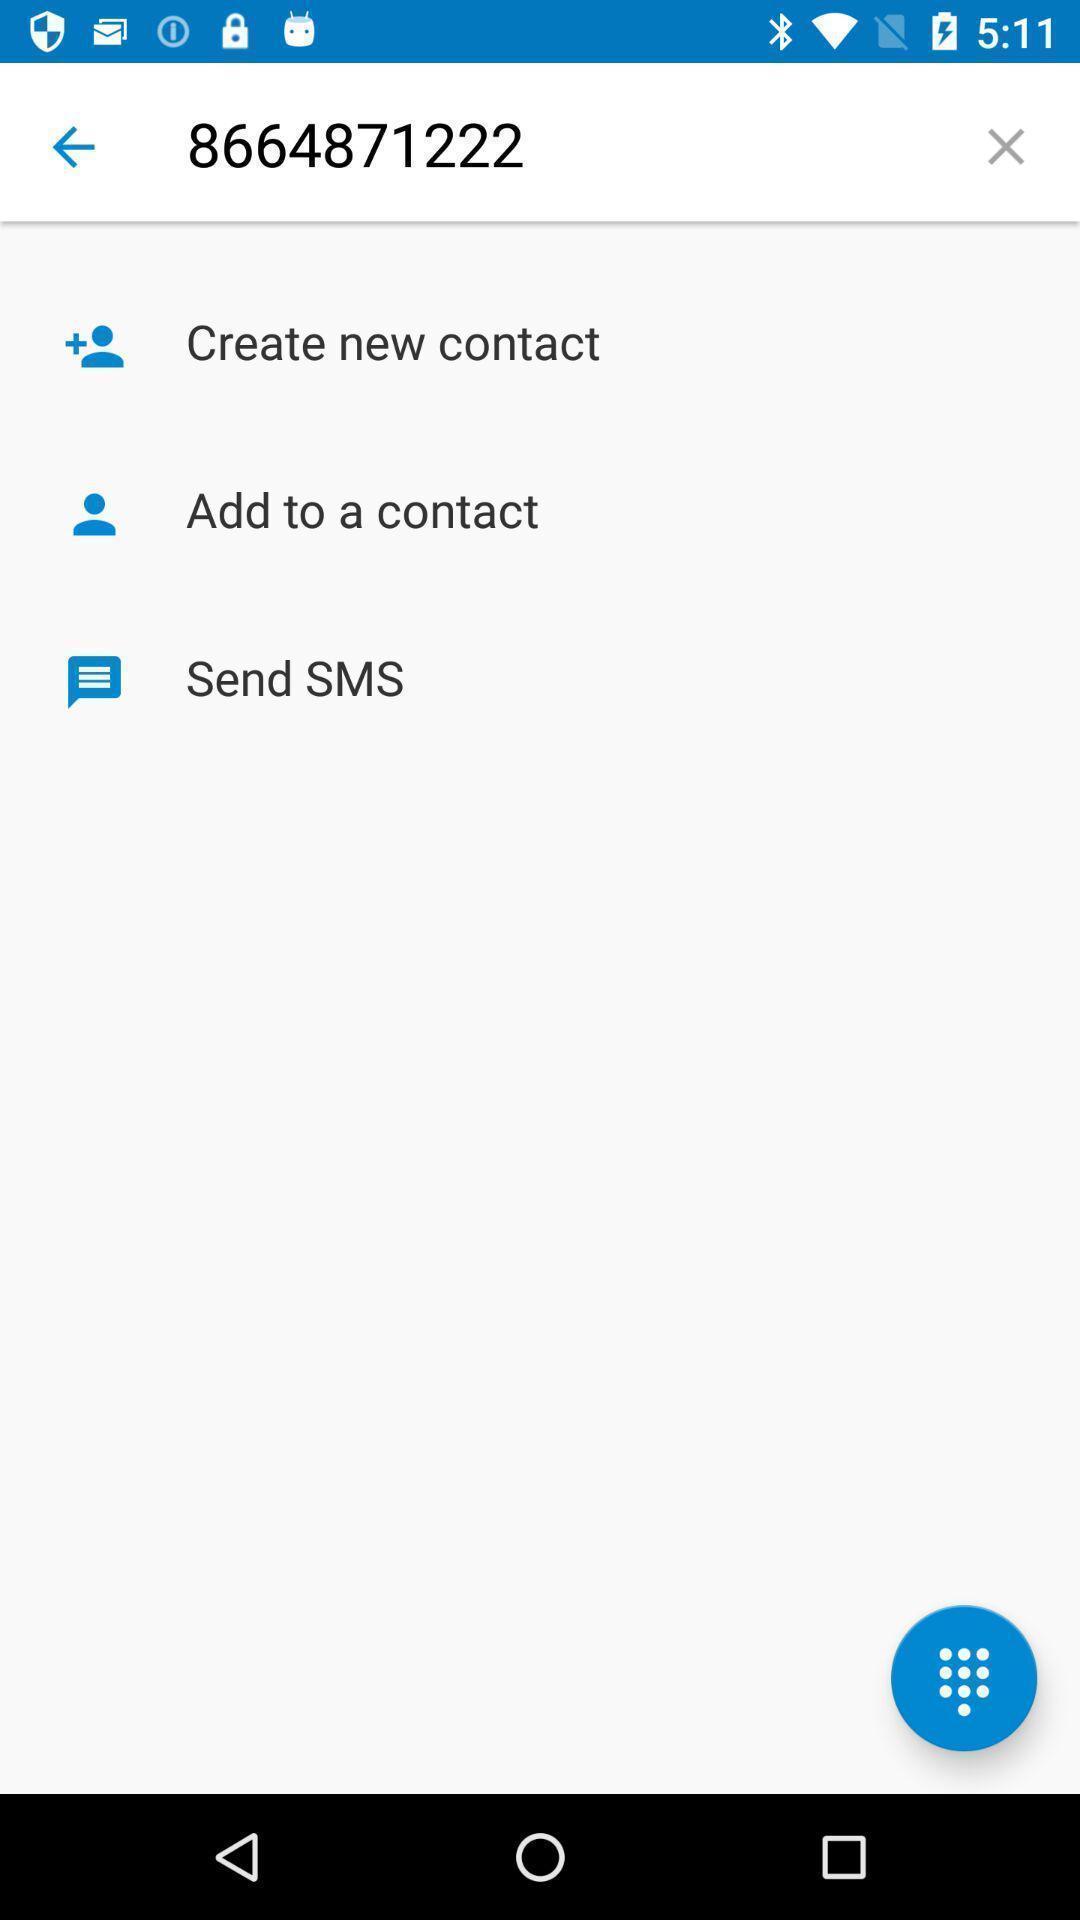Provide a textual representation of this image. Screen shows to create a contact. 